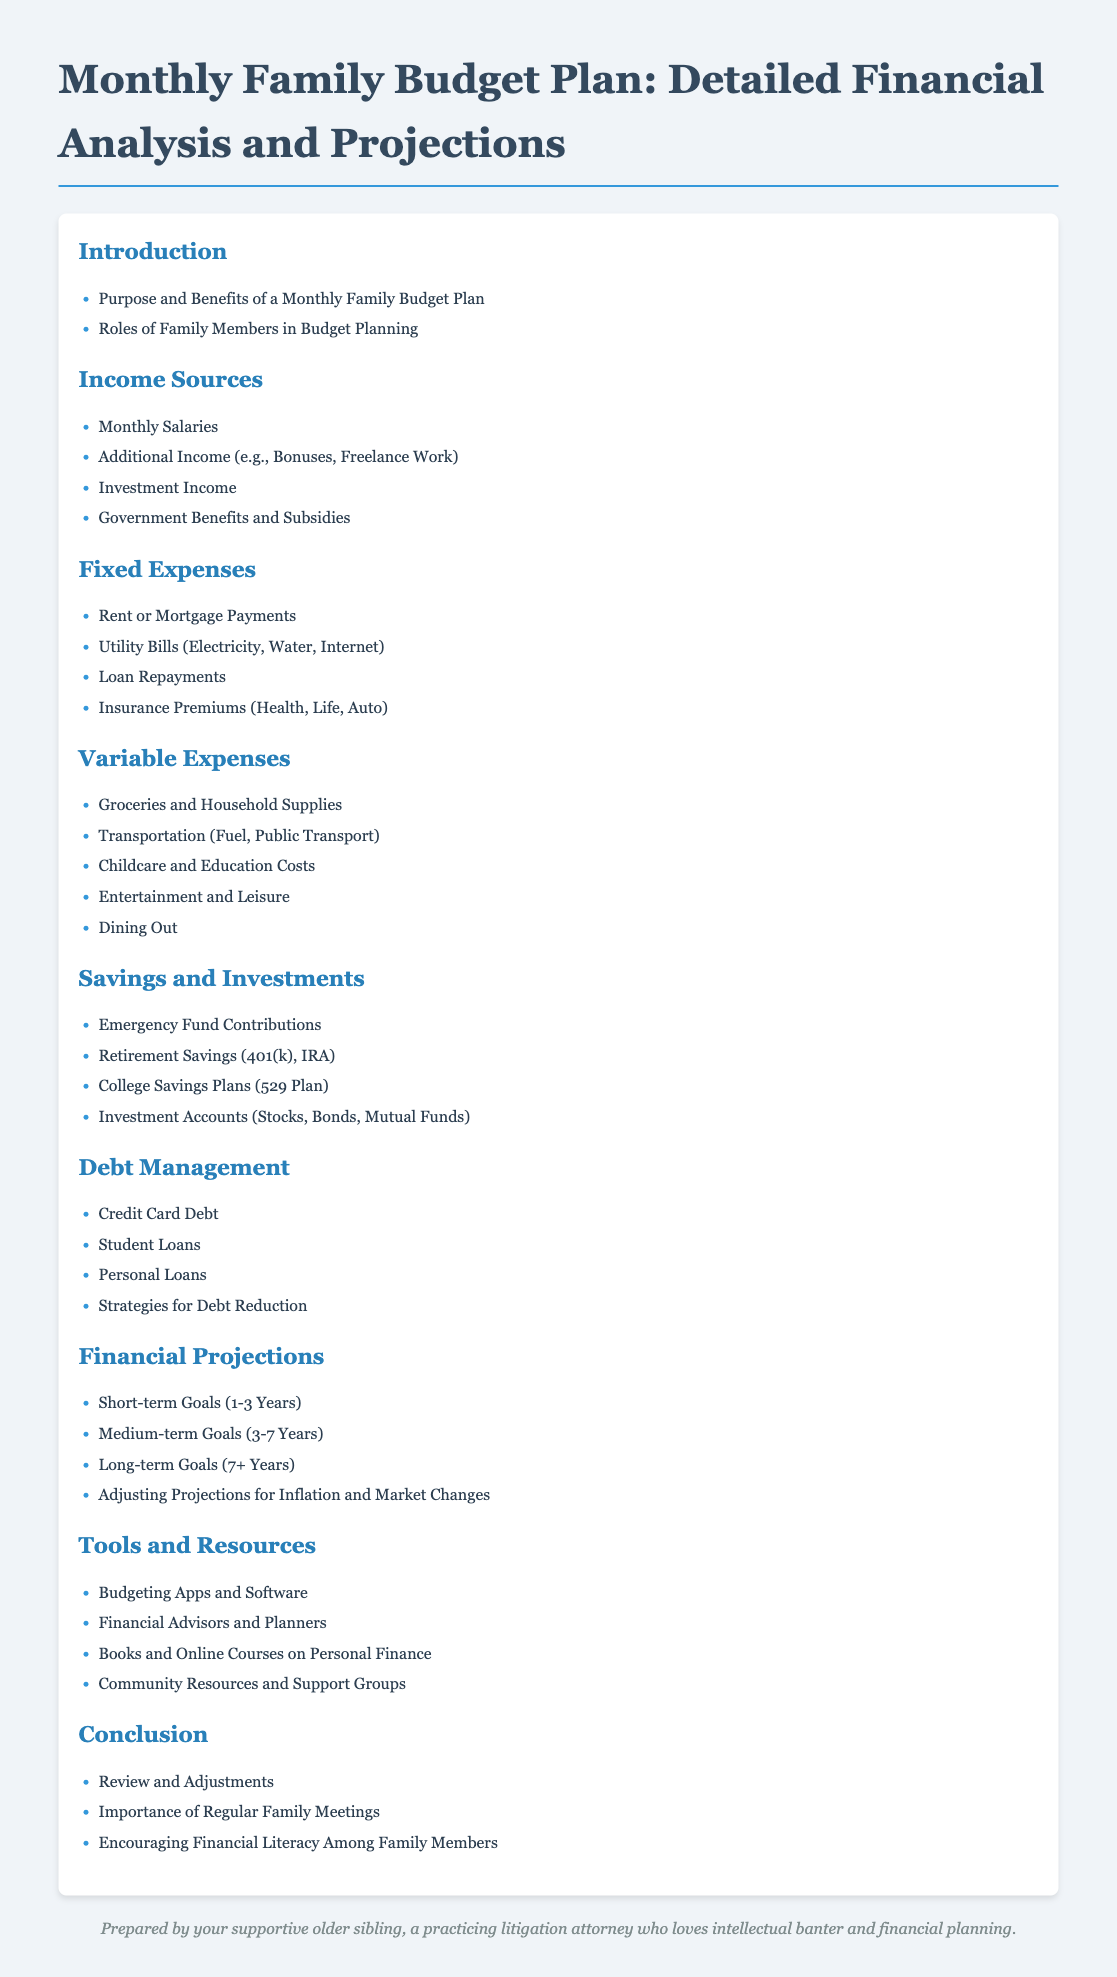what is the first topic under the Introduction section? The first topic listed under the Introduction section is "Purpose and Benefits of a Monthly Family Budget Plan."
Answer: Purpose and Benefits of a Monthly Family Budget Plan how many sources of income are listed? There are four sources of income listed under the Income Sources section.
Answer: 4 what is the main focus of the Fixed Expenses section? The main focus is on the various fixed costs a family incurs, such as rent, utilities, and insurance.
Answer: Fixed costs which type of savings plan is mentioned in the Savings and Investments section? The College Savings Plans (529 Plan) is specifically mentioned in the Savings and Investments section.
Answer: College Savings Plans (529 Plan) what is the last topic listed in the Conclusion section? The last topic listed in the Conclusion section is "Encouraging Financial Literacy Among Family Members."
Answer: Encouraging Financial Literacy Among Family Members how many types of debt are identified in the Debt Management section? Four types of debt are identified in the Debt Management section.
Answer: 4 what are the time frames covered in the Financial Projections section? The time frames mentioned are short-term (1-3 Years), medium-term (3-7 Years), and long-term (7+ Years).
Answer: short-term, medium-term, long-term what resource type is included under the Tools and Resources section? Budgeting Apps and Software is included as a resource type.
Answer: Budgeting Apps and Software 